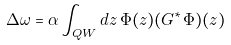Convert formula to latex. <formula><loc_0><loc_0><loc_500><loc_500>\Delta \omega = \alpha \int _ { Q W } d z \, \Phi ( z ) ( G ^ { * } \Phi ) ( z )</formula> 